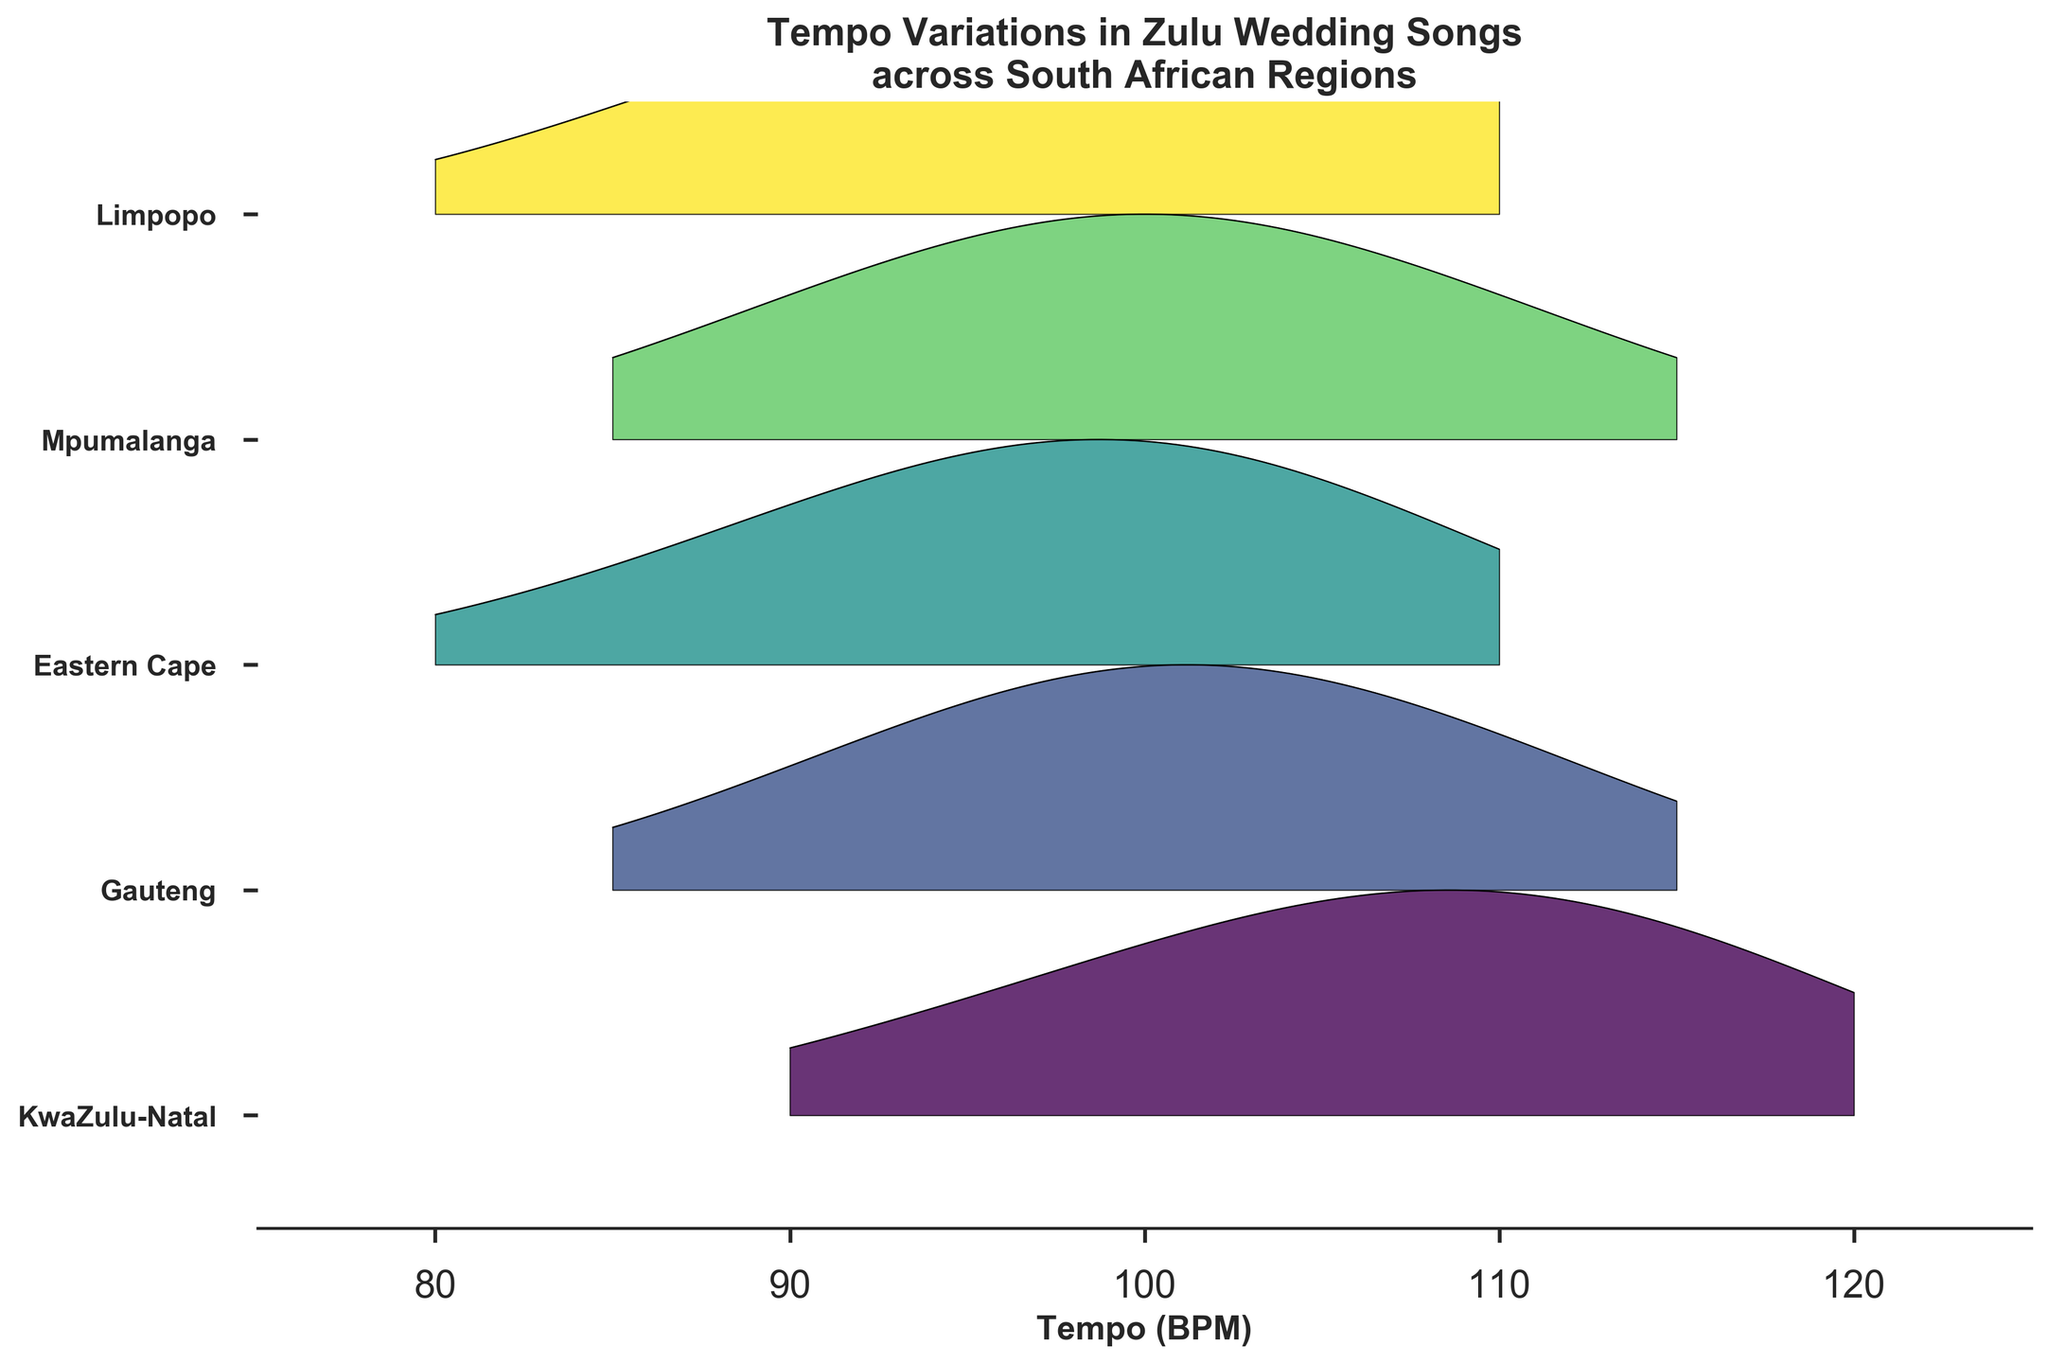What is the title of the figure? The title of the figure is provided at the top and gives a summary of what the plot represents.
Answer: Tempo Variations in Zulu Wedding Songs across South African Regions Which region shows the highest density at 100 BPM? By looking at the peaks at 100 BPM, we can identify which region has the highest density. The region with the tallest peak at 100 BPM is Limpopo.
Answer: Limpopo What tempo range is shown on the x-axis? By examining the x-axis labels and limits, we can determine the range of tempos being analyzed in the figure. The labels indicate that it ranges from 75 to 125 BPM.
Answer: 75 to 125 BPM How many regions are represented in the figure? By counting the number of distinct colored bands or lower y-axis tick labels, we can determine the number of regions represented. There are five distinct regions shown.
Answer: Five Which region has the widest tempo distribution? By comparing the spread of densities across tempos for each region, we can see that the region with the widest tempo distribution is Mpumalanga.
Answer: Mpumalanga At what tempo does KwaZulu-Natal reach its highest density? By locating the peak density for KwaZulu-Natal on the graph, we can determine that it occurs at 110 BPM.
Answer: 110 BPM Which two regions have a peak density at 100 BPM? By examining the ridgelines and identifying the peaks at 100 BPM, we see that both the Eastern Cape and Limpopo have notable peaks at this tempo.
Answer: Eastern Cape and Limpopo Which region has the lowest density at 90 BPM? By comparing the densities at 90 BPM for each region on the graph, we can see that Gauteng has the lowest density at this tempo.
Answer: Gauteng Is the density for Mpumalanga at 100 BPM higher or lower than the density for Gauteng at 100 BPM? By comparing the density values at 100 BPM for Mpumalanga and Gauteng, we can see that Mpumalanga has a taller peak, indicating a higher density.
Answer: Higher Based on the plot, which region has more varied tempo in wedding songs, KwaZulu-Natal or Gauteng? By observing the spread and peaks of the densities, we can conclude that KwaZulu-Natal has more varied tempos as it has a broader range of prominent peaks.
Answer: KwaZulu-Natal 